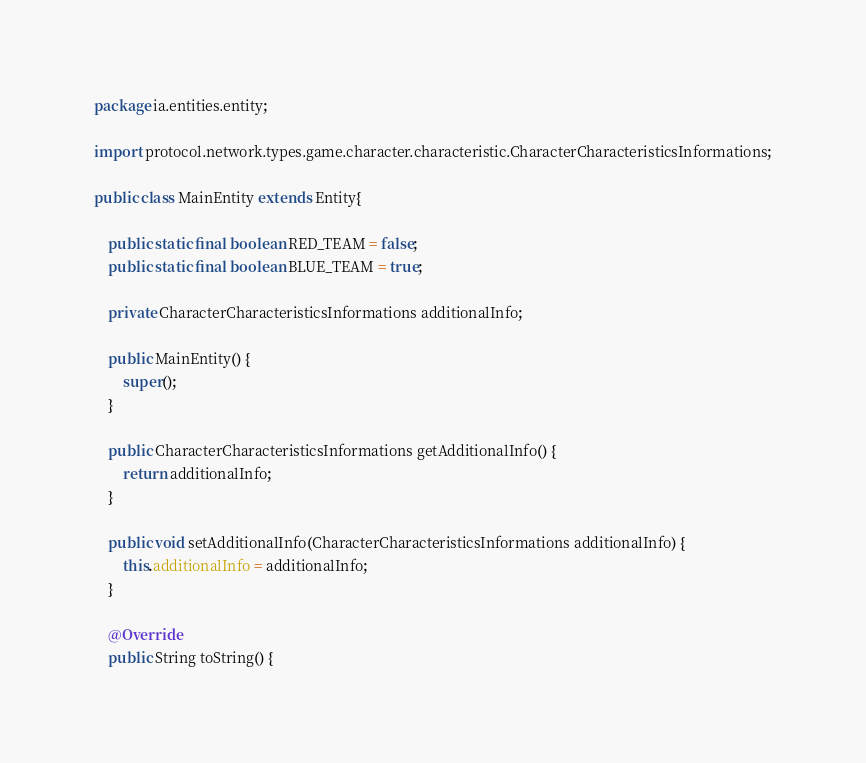<code> <loc_0><loc_0><loc_500><loc_500><_Java_>package ia.entities.entity;

import protocol.network.types.game.character.characteristic.CharacterCharacteristicsInformations;

public class MainEntity extends Entity{
	
	public static final boolean RED_TEAM = false;
	public static final boolean BLUE_TEAM = true;
	
	private CharacterCharacteristicsInformations additionalInfo;

	public MainEntity() {
		super();
	}

    public CharacterCharacteristicsInformations getAdditionalInfo() {
        return additionalInfo;
    }

    public void setAdditionalInfo(CharacterCharacteristicsInformations additionalInfo) {
        this.additionalInfo = additionalInfo;
    }

	@Override
	public String toString() {</code> 